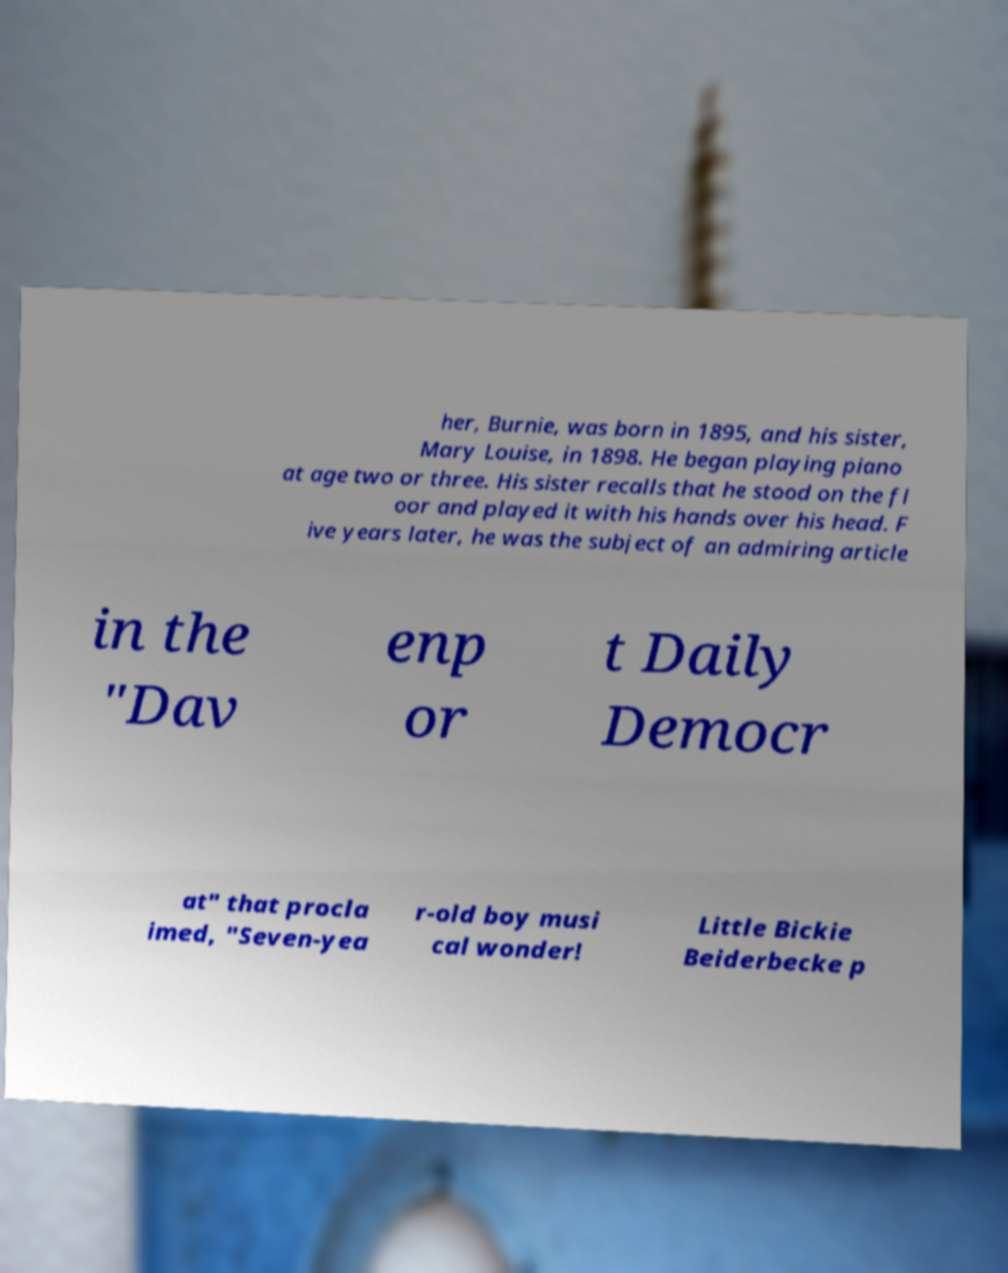Please read and relay the text visible in this image. What does it say? her, Burnie, was born in 1895, and his sister, Mary Louise, in 1898. He began playing piano at age two or three. His sister recalls that he stood on the fl oor and played it with his hands over his head. F ive years later, he was the subject of an admiring article in the "Dav enp or t Daily Democr at" that procla imed, "Seven-yea r-old boy musi cal wonder! Little Bickie Beiderbecke p 